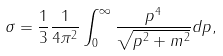<formula> <loc_0><loc_0><loc_500><loc_500>\sigma = \frac { 1 } { 3 } \frac { 1 } { 4 \pi ^ { 2 } } \int _ { 0 } ^ { \infty } \frac { p ^ { 4 } } { \sqrt { p ^ { 2 } + m ^ { 2 } } } d p ,</formula> 